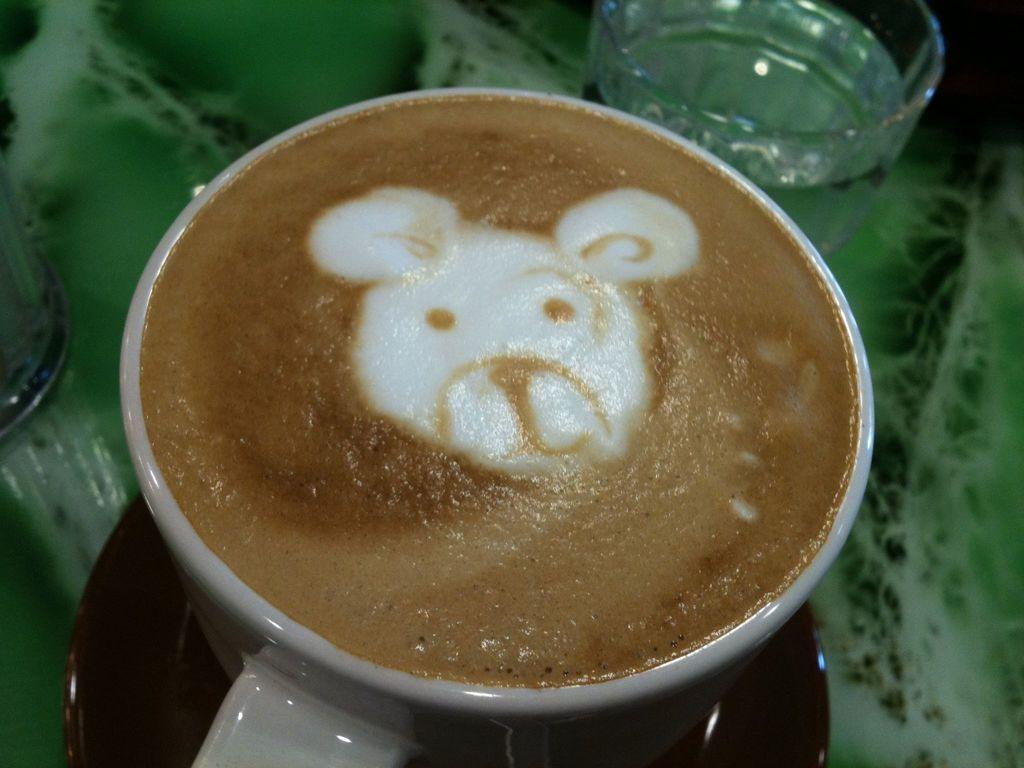Please provide a concise description of this image. In this picture we can see the liquid and the shape of an animal in the cup. This cup is visible on a saucer. We can see the liquid in the glass. There is an object on the left side. 